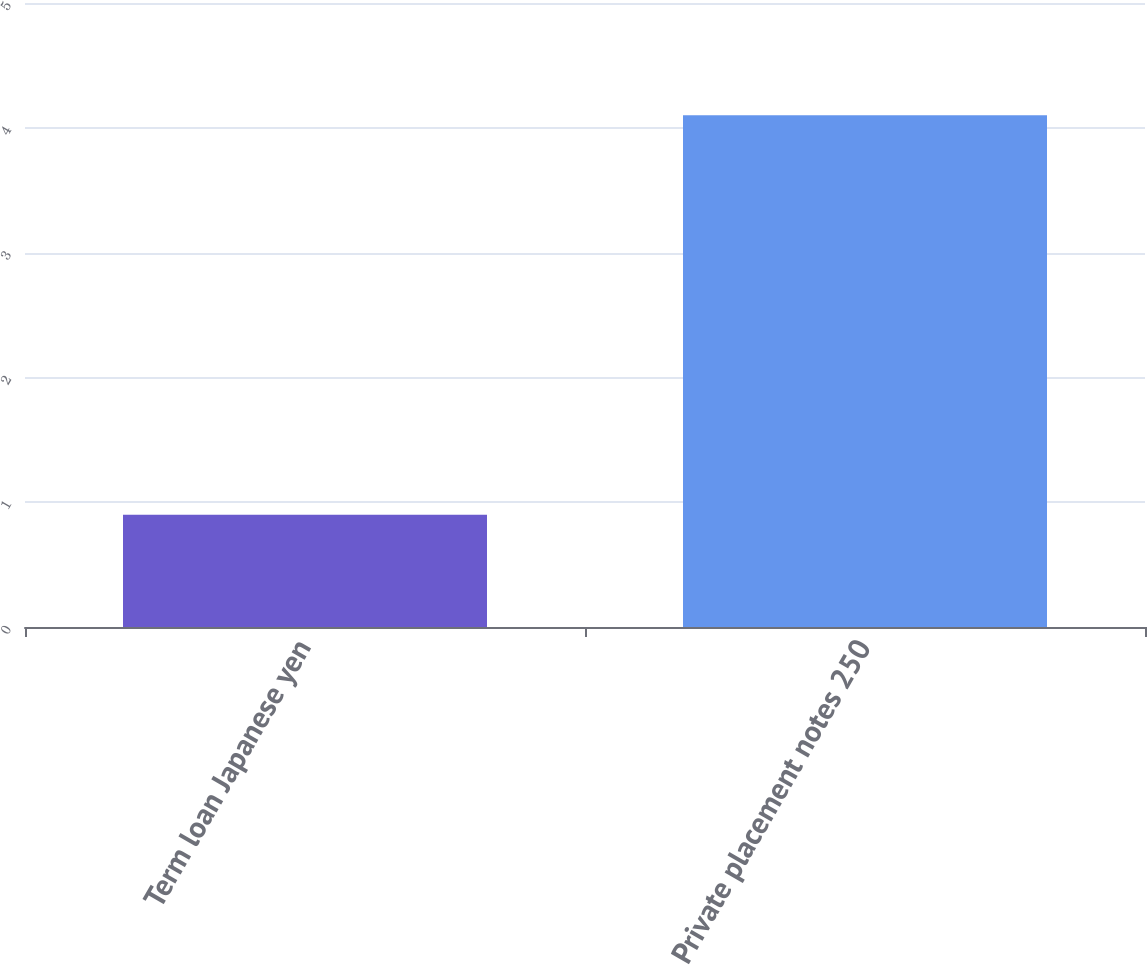Convert chart to OTSL. <chart><loc_0><loc_0><loc_500><loc_500><bar_chart><fcel>Term loan Japanese yen<fcel>Private placement notes 250<nl><fcel>0.9<fcel>4.1<nl></chart> 